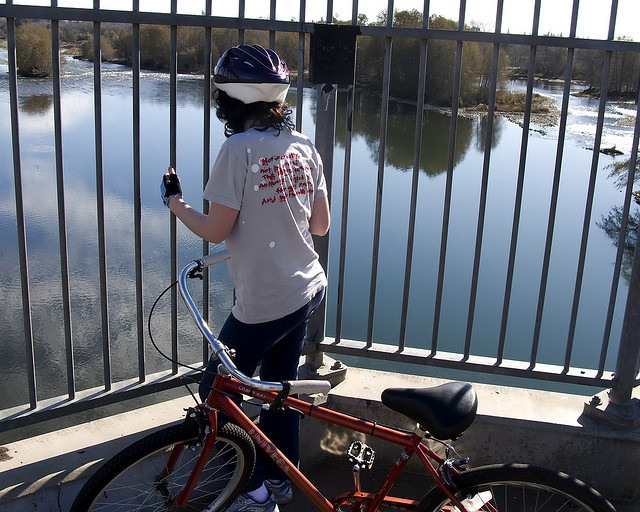Describe the objects in this image and their specific colors. I can see people in white, black, gray, and darkgray tones and bicycle in white, black, gray, and maroon tones in this image. 